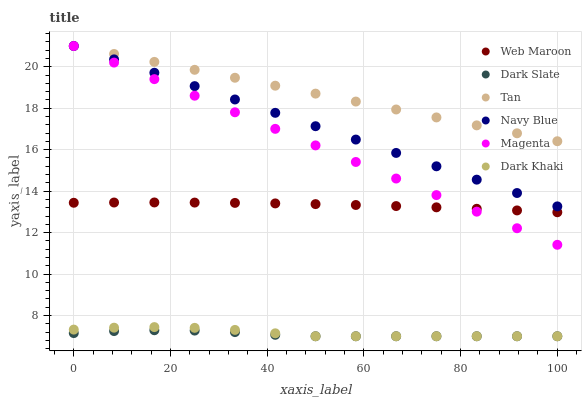Does Dark Slate have the minimum area under the curve?
Answer yes or no. Yes. Does Tan have the maximum area under the curve?
Answer yes or no. Yes. Does Web Maroon have the minimum area under the curve?
Answer yes or no. No. Does Web Maroon have the maximum area under the curve?
Answer yes or no. No. Is Magenta the smoothest?
Answer yes or no. Yes. Is Dark Khaki the roughest?
Answer yes or no. Yes. Is Web Maroon the smoothest?
Answer yes or no. No. Is Web Maroon the roughest?
Answer yes or no. No. Does Dark Khaki have the lowest value?
Answer yes or no. Yes. Does Web Maroon have the lowest value?
Answer yes or no. No. Does Magenta have the highest value?
Answer yes or no. Yes. Does Web Maroon have the highest value?
Answer yes or no. No. Is Dark Slate less than Tan?
Answer yes or no. Yes. Is Tan greater than Dark Slate?
Answer yes or no. Yes. Does Magenta intersect Navy Blue?
Answer yes or no. Yes. Is Magenta less than Navy Blue?
Answer yes or no. No. Is Magenta greater than Navy Blue?
Answer yes or no. No. Does Dark Slate intersect Tan?
Answer yes or no. No. 